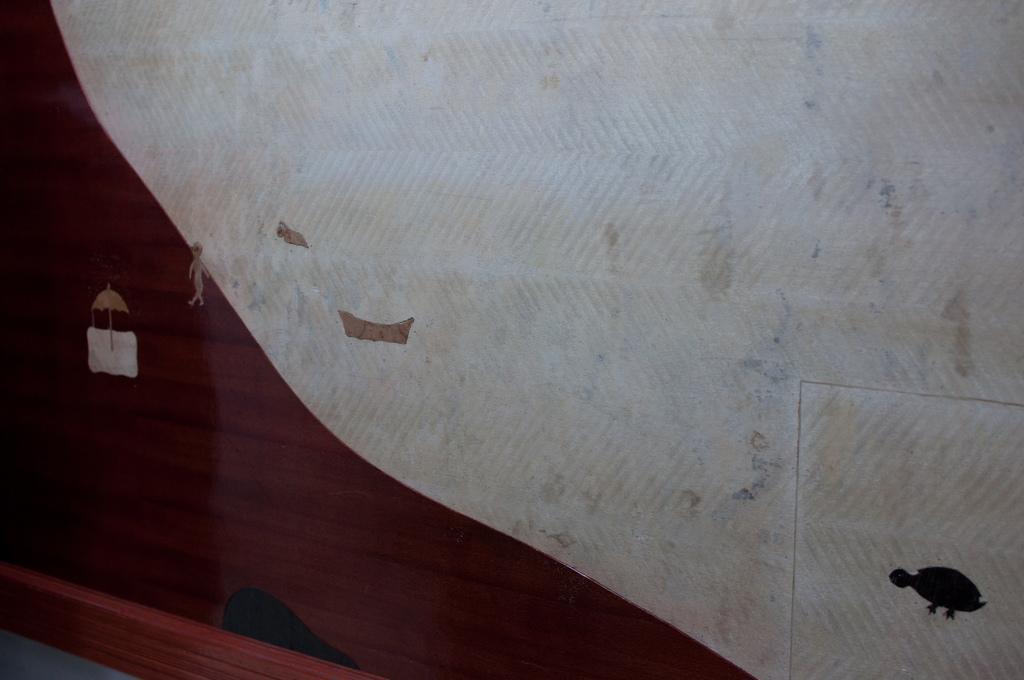How would you summarize this image in a sentence or two? In this image I can see there is a wall with the art of tortoise, man, boat and umbrella. Also there are some other things. 